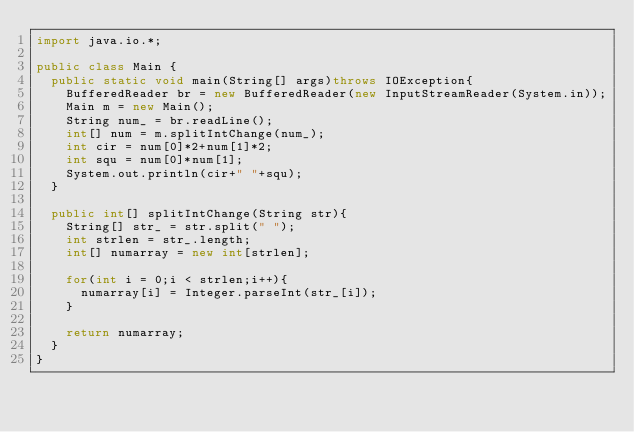<code> <loc_0><loc_0><loc_500><loc_500><_Java_>import java.io.*;

public class Main {
	public static void main(String[] args)throws IOException{
		BufferedReader br = new BufferedReader(new InputStreamReader(System.in));
		Main m = new Main();
		String num_ = br.readLine();
		int[] num = m.splitIntChange(num_);
		int cir = num[0]*2+num[1]*2;
		int squ = num[0]*num[1];
		System.out.println(cir+" "+squ);
	}
	
	public int[] splitIntChange(String str){
		String[] str_ = str.split(" ");
		int strlen = str_.length;
		int[] numarray = new int[strlen];
		
		for(int i = 0;i < strlen;i++){
			numarray[i] = Integer.parseInt(str_[i]); 
		}
		
		return numarray;
	}
}</code> 